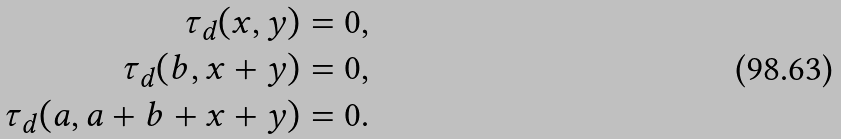<formula> <loc_0><loc_0><loc_500><loc_500>\tau _ { d } ( x , y ) = 0 , \\ \tau _ { d } ( b , x + y ) = 0 , \\ \tau _ { d } ( a , a + b + x + y ) = 0 .</formula> 